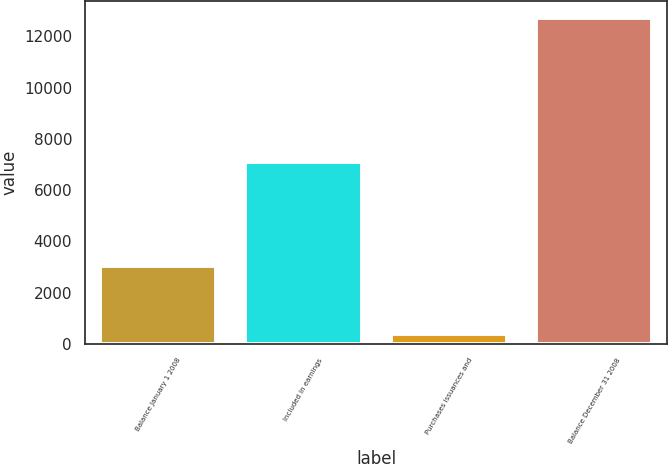Convert chart to OTSL. <chart><loc_0><loc_0><loc_500><loc_500><bar_chart><fcel>Balance January 1 2008<fcel>Included in earnings<fcel>Purchases issuances and<fcel>Balance December 31 2008<nl><fcel>3053<fcel>7115<fcel>393<fcel>12733<nl></chart> 